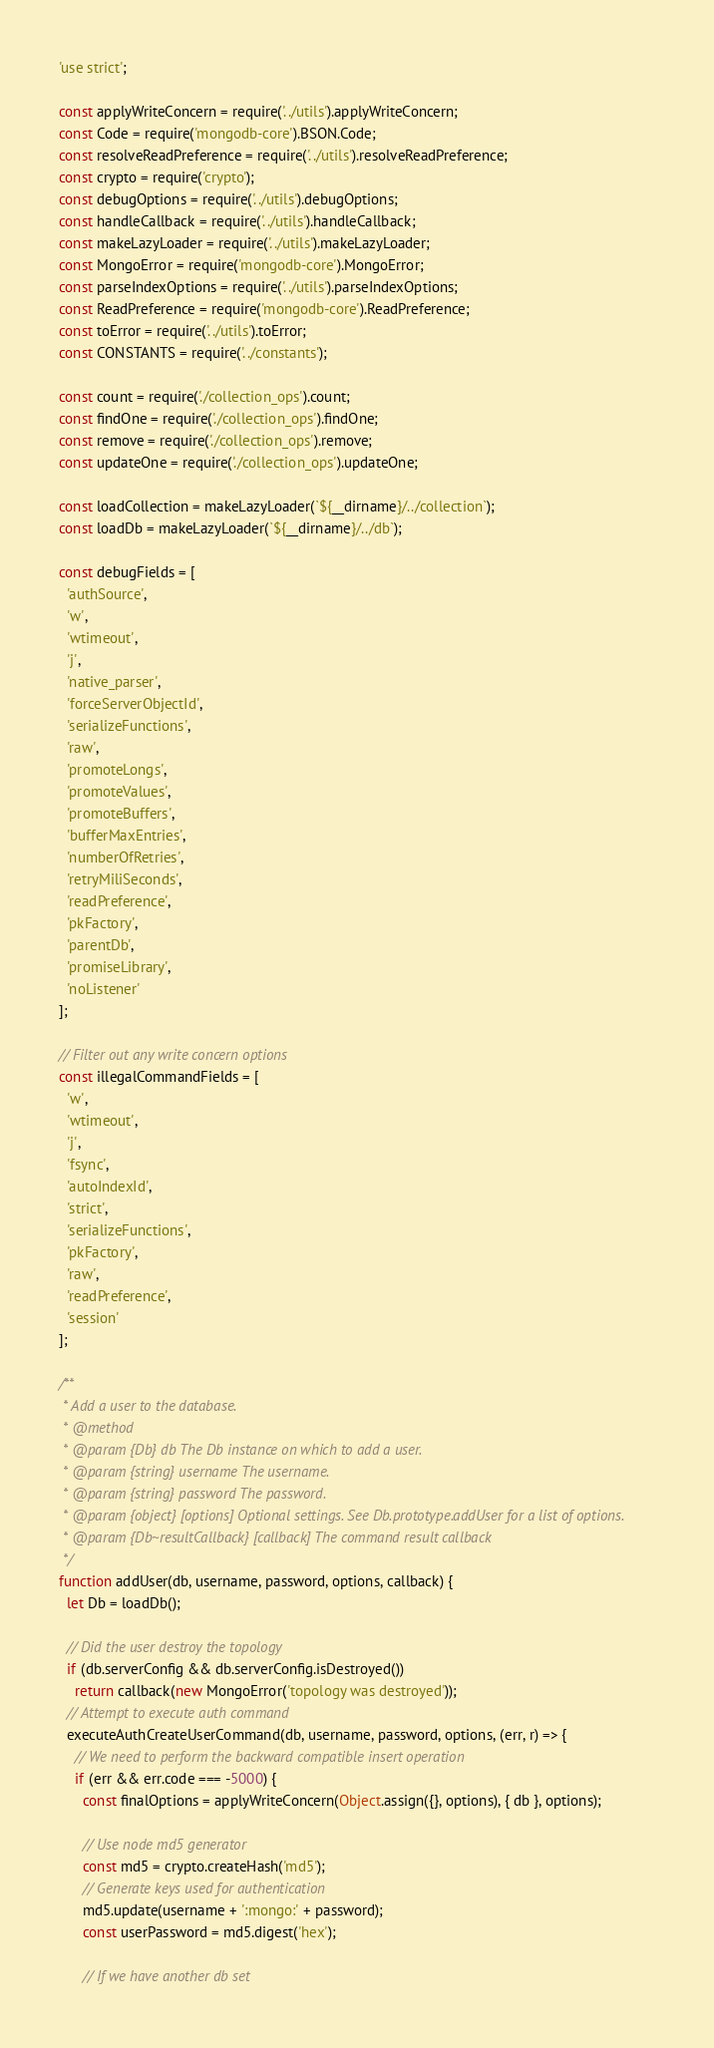Convert code to text. <code><loc_0><loc_0><loc_500><loc_500><_JavaScript_>'use strict';

const applyWriteConcern = require('../utils').applyWriteConcern;
const Code = require('mongodb-core').BSON.Code;
const resolveReadPreference = require('../utils').resolveReadPreference;
const crypto = require('crypto');
const debugOptions = require('../utils').debugOptions;
const handleCallback = require('../utils').handleCallback;
const makeLazyLoader = require('../utils').makeLazyLoader;
const MongoError = require('mongodb-core').MongoError;
const parseIndexOptions = require('../utils').parseIndexOptions;
const ReadPreference = require('mongodb-core').ReadPreference;
const toError = require('../utils').toError;
const CONSTANTS = require('../constants');

const count = require('./collection_ops').count;
const findOne = require('./collection_ops').findOne;
const remove = require('./collection_ops').remove;
const updateOne = require('./collection_ops').updateOne;

const loadCollection = makeLazyLoader(`${__dirname}/../collection`);
const loadDb = makeLazyLoader(`${__dirname}/../db`);

const debugFields = [
  'authSource',
  'w',
  'wtimeout',
  'j',
  'native_parser',
  'forceServerObjectId',
  'serializeFunctions',
  'raw',
  'promoteLongs',
  'promoteValues',
  'promoteBuffers',
  'bufferMaxEntries',
  'numberOfRetries',
  'retryMiliSeconds',
  'readPreference',
  'pkFactory',
  'parentDb',
  'promiseLibrary',
  'noListener'
];

// Filter out any write concern options
const illegalCommandFields = [
  'w',
  'wtimeout',
  'j',
  'fsync',
  'autoIndexId',
  'strict',
  'serializeFunctions',
  'pkFactory',
  'raw',
  'readPreference',
  'session'
];

/**
 * Add a user to the database.
 * @method
 * @param {Db} db The Db instance on which to add a user.
 * @param {string} username The username.
 * @param {string} password The password.
 * @param {object} [options] Optional settings. See Db.prototype.addUser for a list of options.
 * @param {Db~resultCallback} [callback] The command result callback
 */
function addUser(db, username, password, options, callback) {
  let Db = loadDb();

  // Did the user destroy the topology
  if (db.serverConfig && db.serverConfig.isDestroyed())
    return callback(new MongoError('topology was destroyed'));
  // Attempt to execute auth command
  executeAuthCreateUserCommand(db, username, password, options, (err, r) => {
    // We need to perform the backward compatible insert operation
    if (err && err.code === -5000) {
      const finalOptions = applyWriteConcern(Object.assign({}, options), { db }, options);

      // Use node md5 generator
      const md5 = crypto.createHash('md5');
      // Generate keys used for authentication
      md5.update(username + ':mongo:' + password);
      const userPassword = md5.digest('hex');

      // If we have another db set</code> 